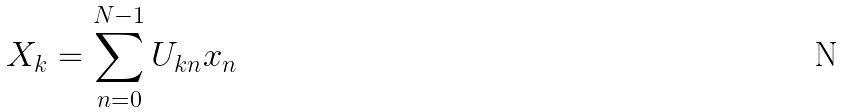Convert formula to latex. <formula><loc_0><loc_0><loc_500><loc_500>X _ { k } = \sum _ { n = 0 } ^ { N - 1 } U _ { k n } x _ { n }</formula> 